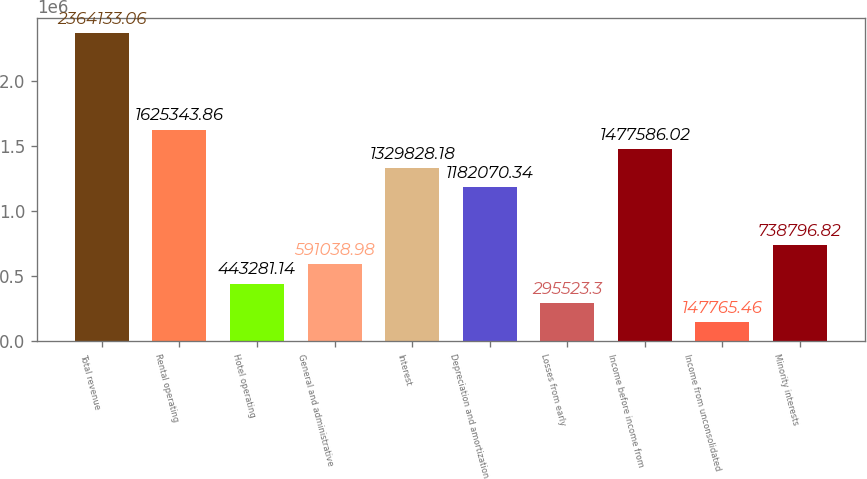<chart> <loc_0><loc_0><loc_500><loc_500><bar_chart><fcel>Total revenue<fcel>Rental operating<fcel>Hotel operating<fcel>General and administrative<fcel>Interest<fcel>Depreciation and amortization<fcel>Losses from early<fcel>Income before income from<fcel>Income from unconsolidated<fcel>Minority interests<nl><fcel>2.36413e+06<fcel>1.62534e+06<fcel>443281<fcel>591039<fcel>1.32983e+06<fcel>1.18207e+06<fcel>295523<fcel>1.47759e+06<fcel>147765<fcel>738797<nl></chart> 